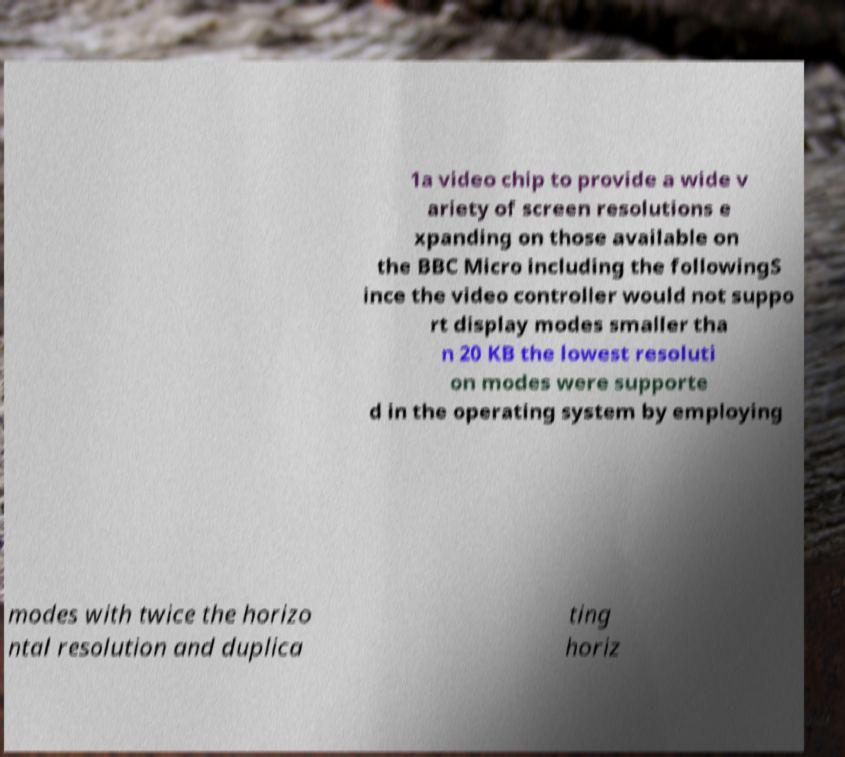There's text embedded in this image that I need extracted. Can you transcribe it verbatim? 1a video chip to provide a wide v ariety of screen resolutions e xpanding on those available on the BBC Micro including the followingS ince the video controller would not suppo rt display modes smaller tha n 20 KB the lowest resoluti on modes were supporte d in the operating system by employing modes with twice the horizo ntal resolution and duplica ting horiz 